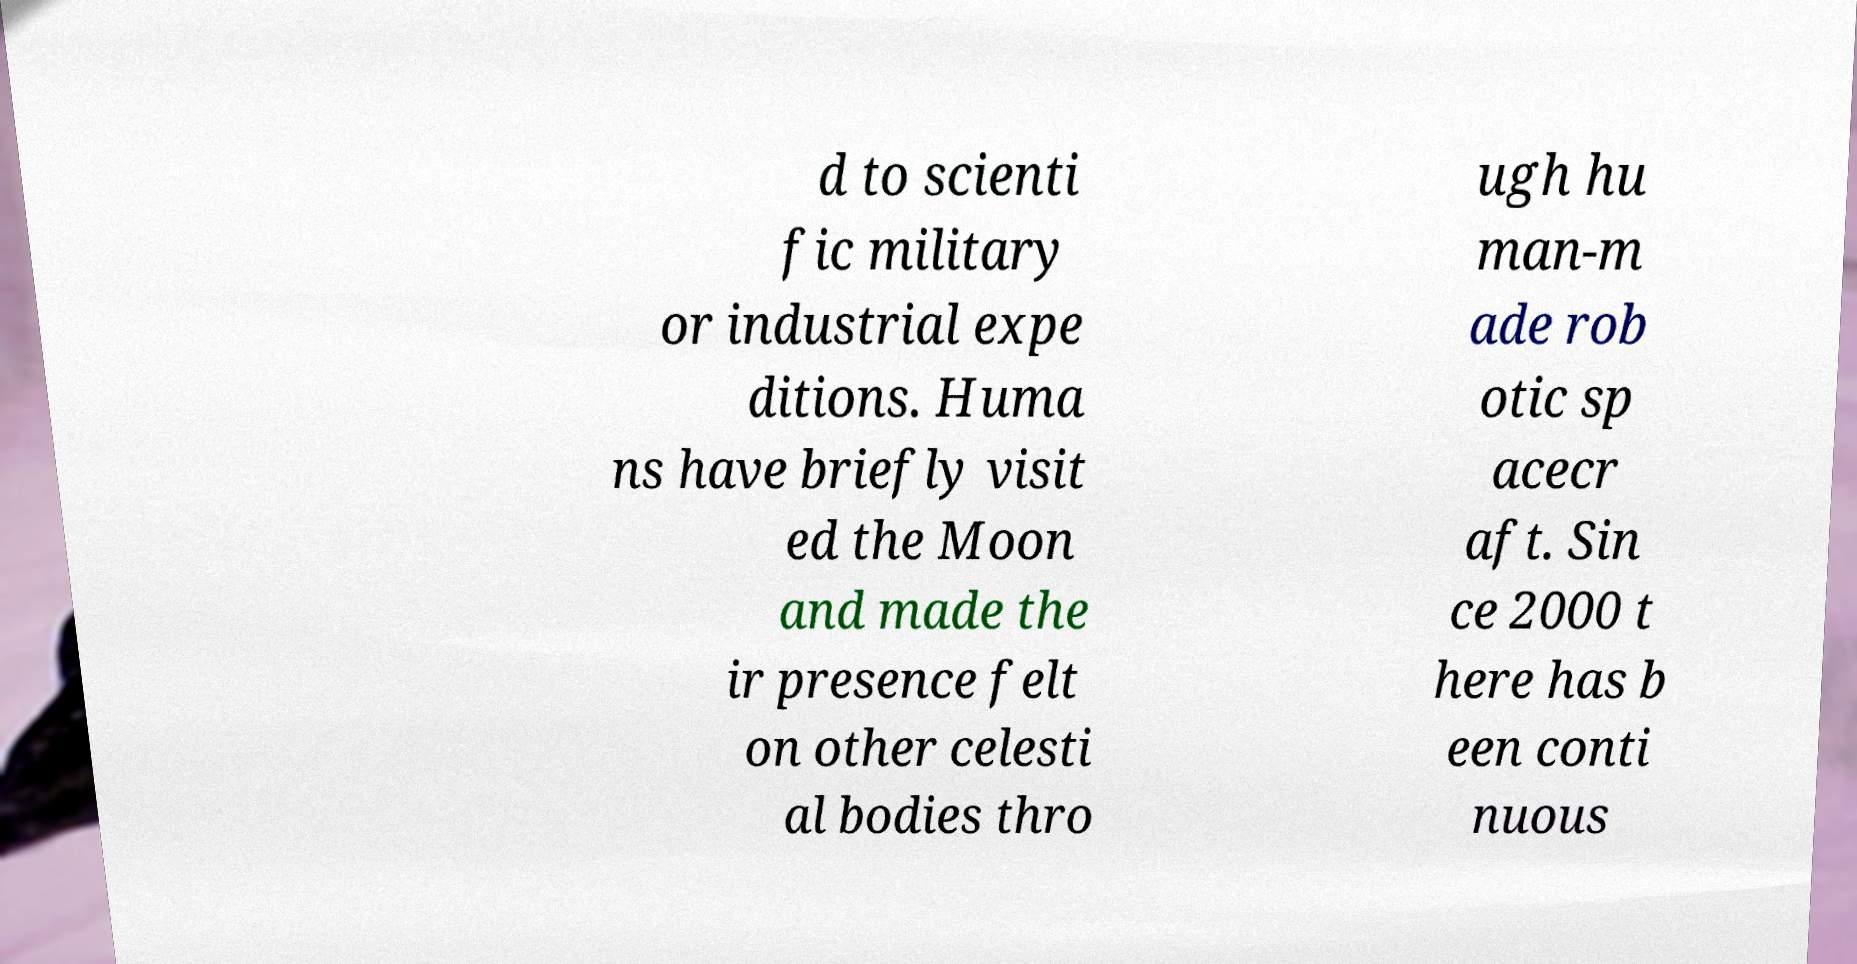Could you assist in decoding the text presented in this image and type it out clearly? d to scienti fic military or industrial expe ditions. Huma ns have briefly visit ed the Moon and made the ir presence felt on other celesti al bodies thro ugh hu man-m ade rob otic sp acecr aft. Sin ce 2000 t here has b een conti nuous 